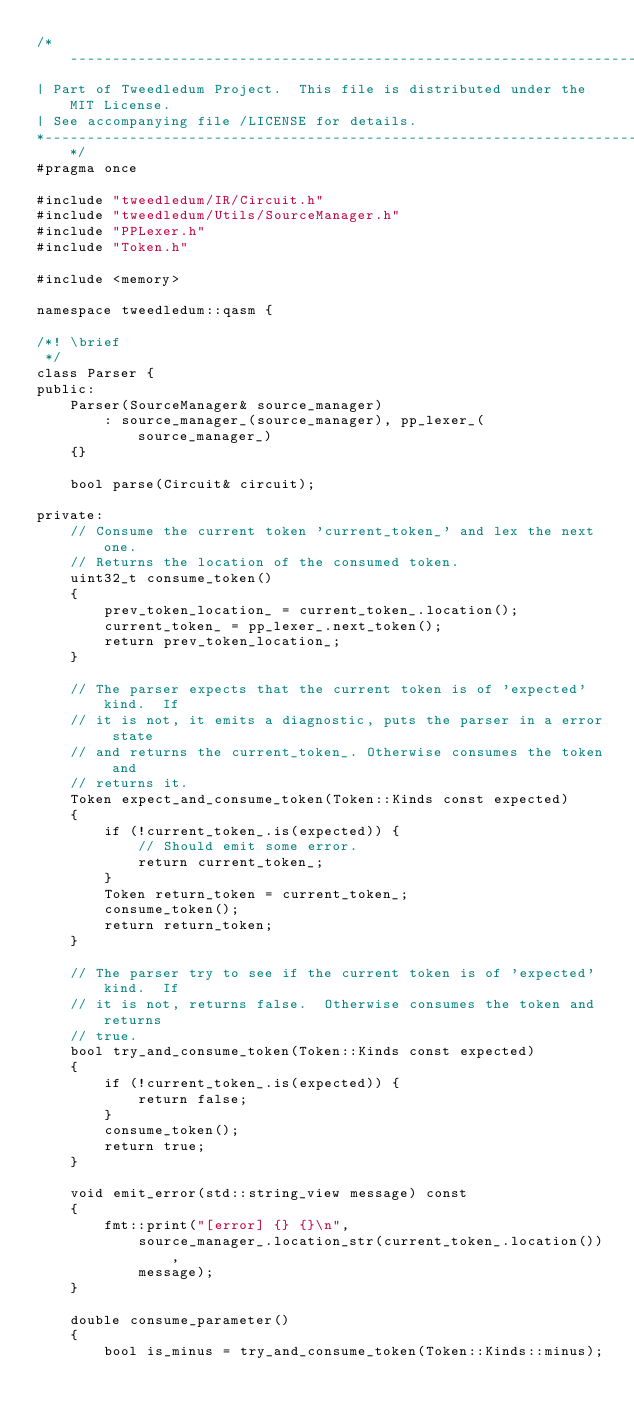Convert code to text. <code><loc_0><loc_0><loc_500><loc_500><_C_>/*------------------------------------------------------------------------------
| Part of Tweedledum Project.  This file is distributed under the MIT License.
| See accompanying file /LICENSE for details.
*-----------------------------------------------------------------------------*/
#pragma once

#include "tweedledum/IR/Circuit.h"
#include "tweedledum/Utils/SourceManager.h"
#include "PPLexer.h"
#include "Token.h"

#include <memory>

namespace tweedledum::qasm {

/*! \brief
 */
class Parser {
public:
    Parser(SourceManager& source_manager)
        : source_manager_(source_manager), pp_lexer_(source_manager_)
    {}

    bool parse(Circuit& circuit);

private:
    // Consume the current token 'current_token_' and lex the next one.
    // Returns the location of the consumed token.
    uint32_t consume_token()
    {
        prev_token_location_ = current_token_.location();
        current_token_ = pp_lexer_.next_token();
        return prev_token_location_;
    }

    // The parser expects that the current token is of 'expected' kind.  If
    // it is not, it emits a diagnostic, puts the parser in a error state
    // and returns the current_token_. Otherwise consumes the token and
    // returns it.
    Token expect_and_consume_token(Token::Kinds const expected)
    {
        if (!current_token_.is(expected)) {
            // Should emit some error.
            return current_token_;
        }
        Token return_token = current_token_;
        consume_token();
        return return_token;
    }

    // The parser try to see if the current token is of 'expected' kind.  If
    // it is not, returns false.  Otherwise consumes the token and returns
    // true.
    bool try_and_consume_token(Token::Kinds const expected)
    {
        if (!current_token_.is(expected)) {
            return false;
        }
        consume_token();
        return true;
    }

    void emit_error(std::string_view message) const
    {
        fmt::print("[error] {} {}\n",
            source_manager_.location_str(current_token_.location()),
            message);
    }

    double consume_parameter()
    {
        bool is_minus = try_and_consume_token(Token::Kinds::minus);</code> 